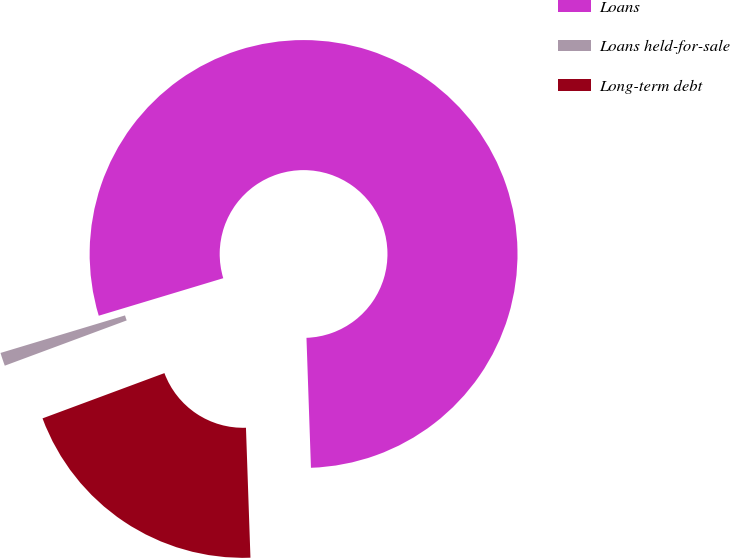Convert chart. <chart><loc_0><loc_0><loc_500><loc_500><pie_chart><fcel>Loans<fcel>Loans held-for-sale<fcel>Long-term debt<nl><fcel>79.11%<fcel>1.0%<fcel>19.89%<nl></chart> 